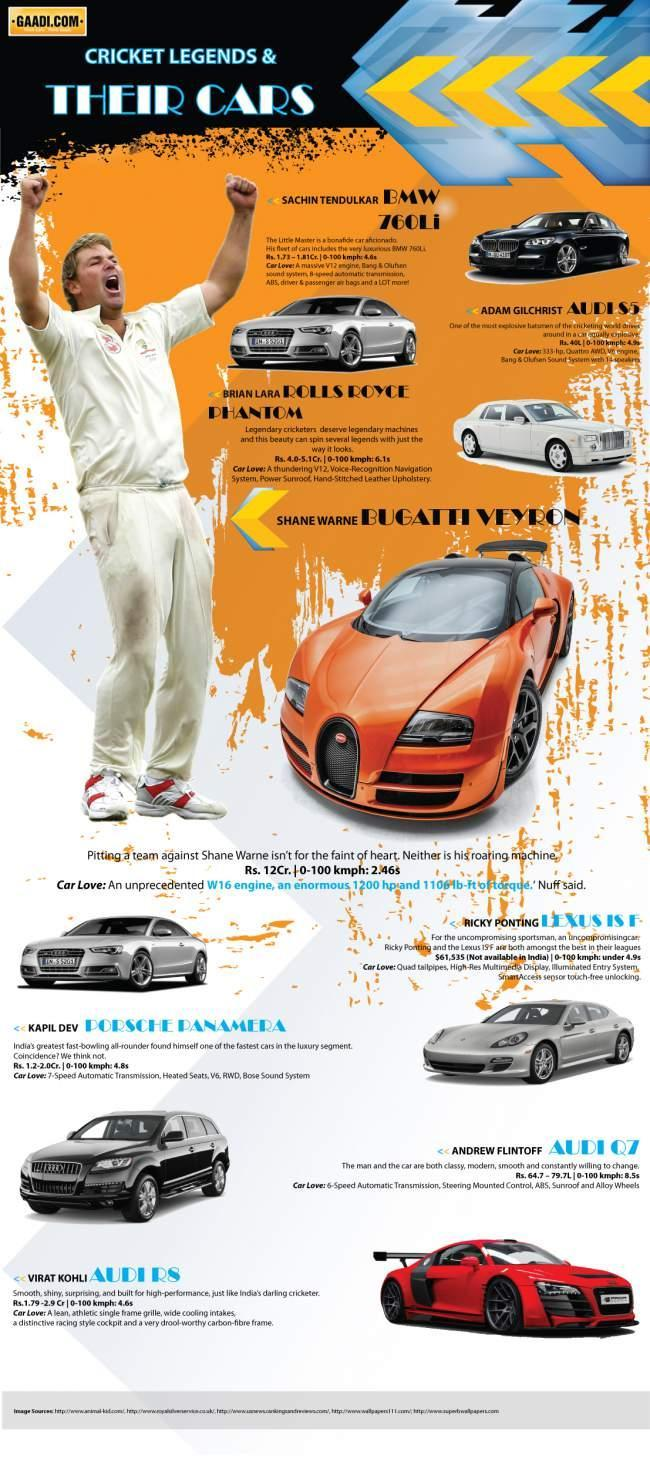What is the name of the car in orange color?
Answer the question with a short phrase. Bugatti Veyron Which are the cricketers who own an Audi car? Adam Gilchrist, Andrew Flintoff, Virat Kohli Which car brand is not available in India, Lexus, Audi, or BMW? Lexus What is color of Audi owned by Kohli, white, silver, black, or red? red What is model number of the car in black? 760Li 